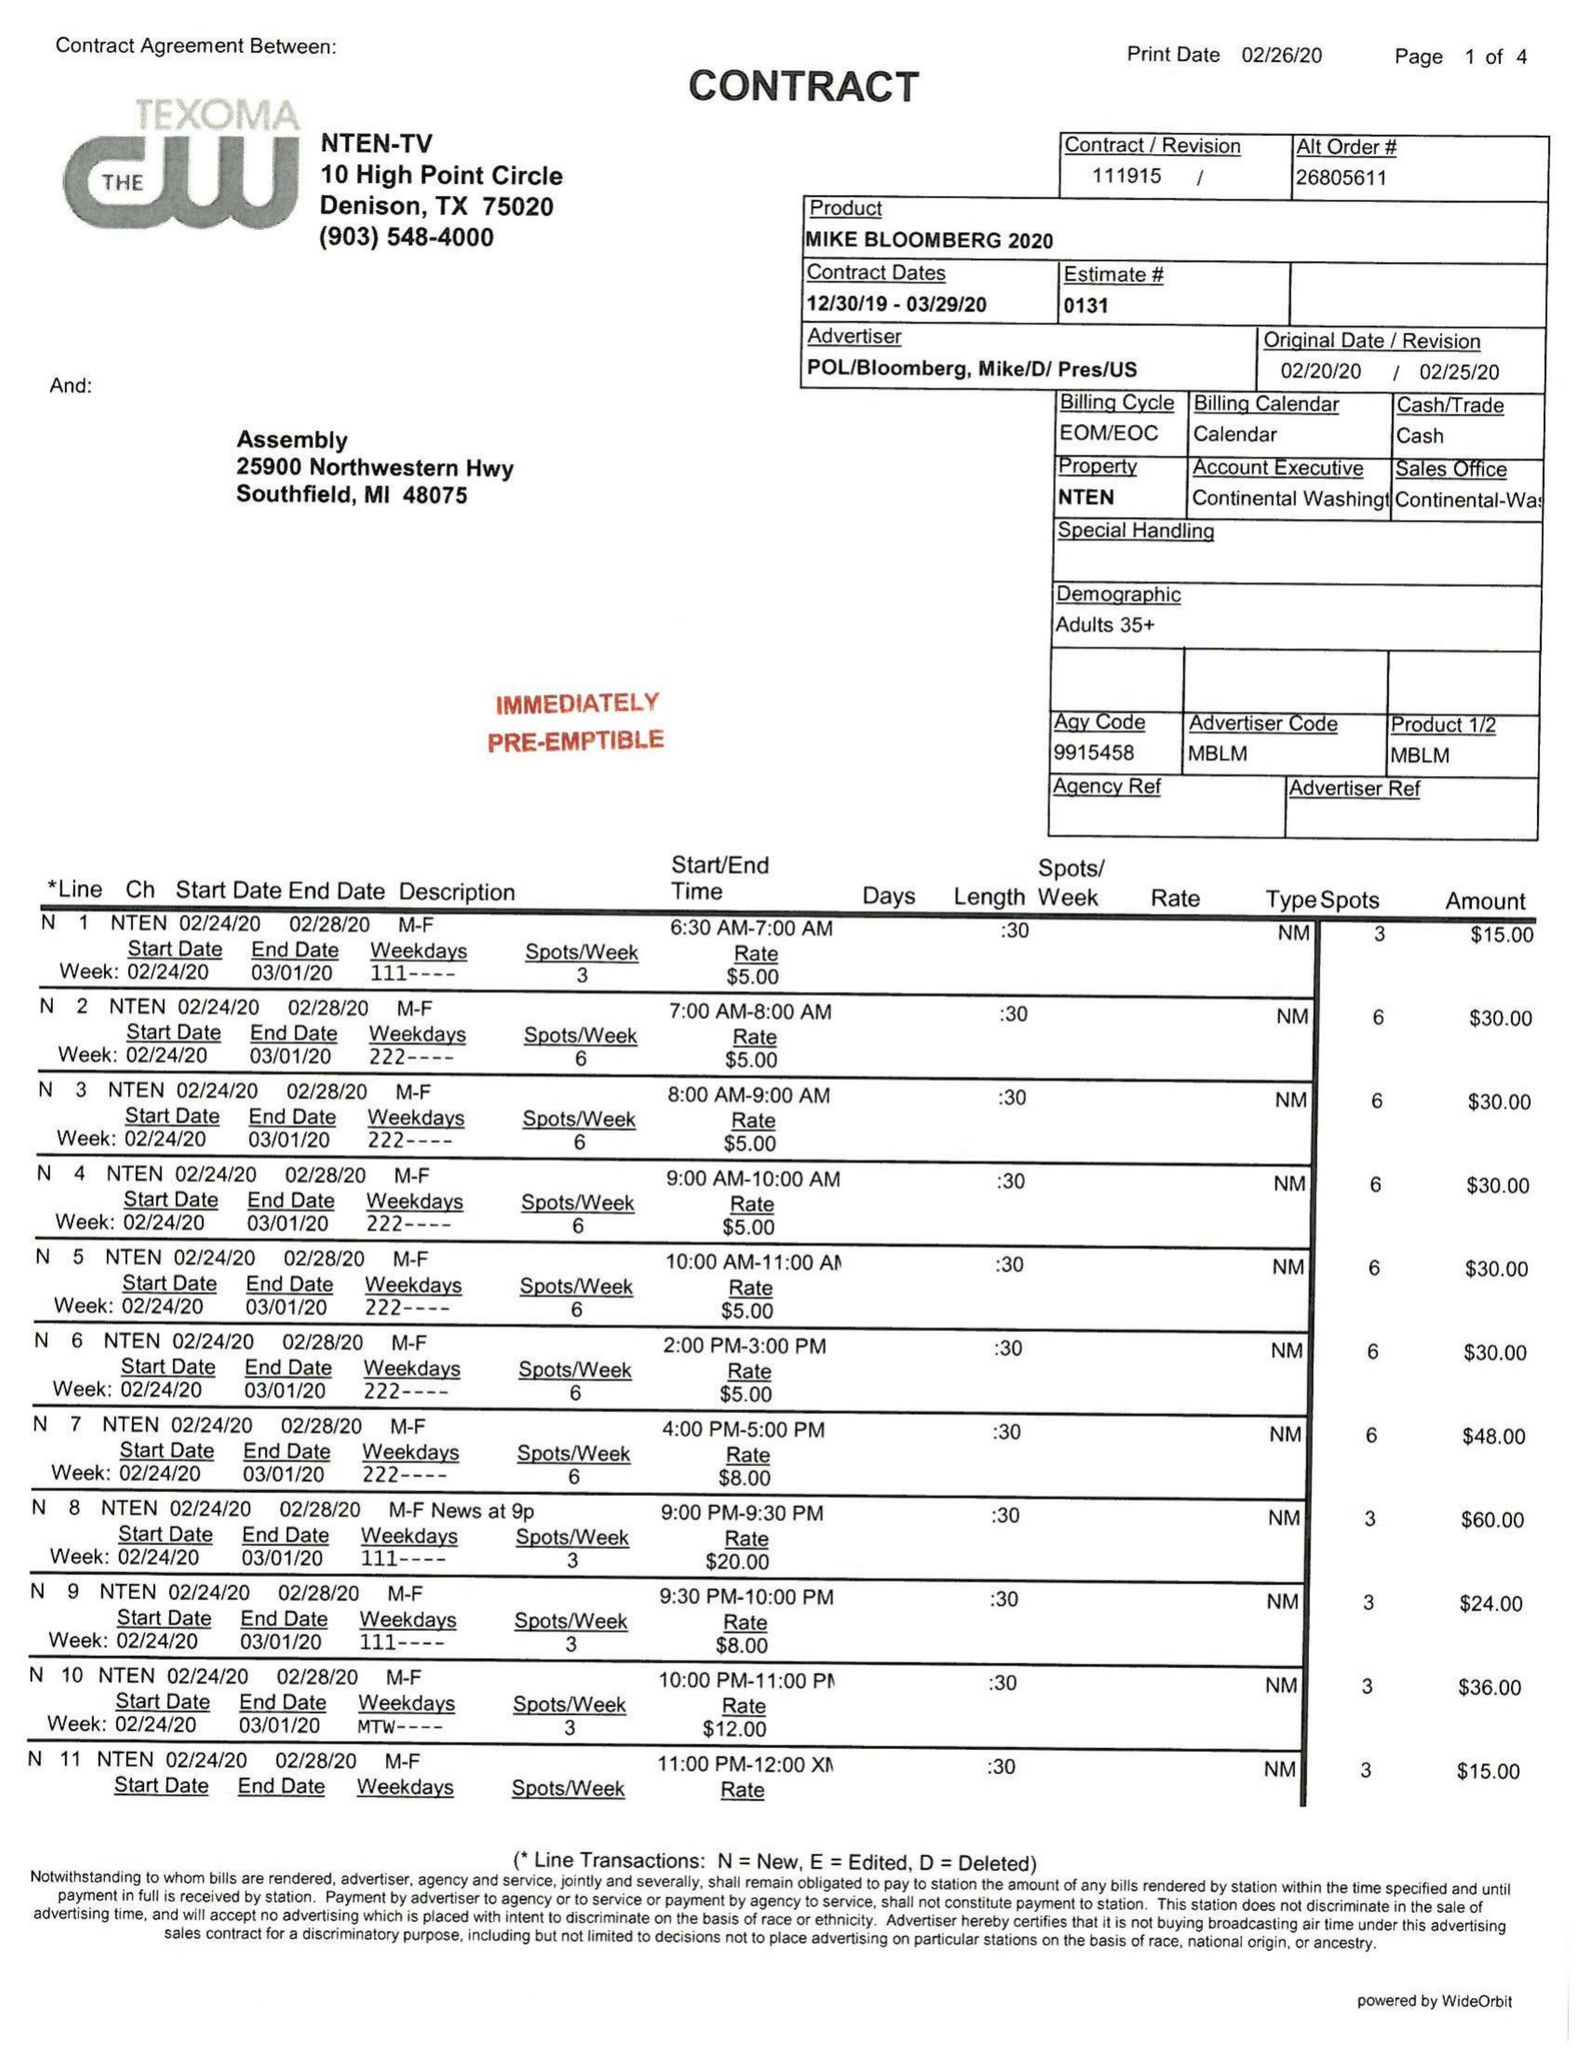What is the value for the contract_num?
Answer the question using a single word or phrase. 111915 